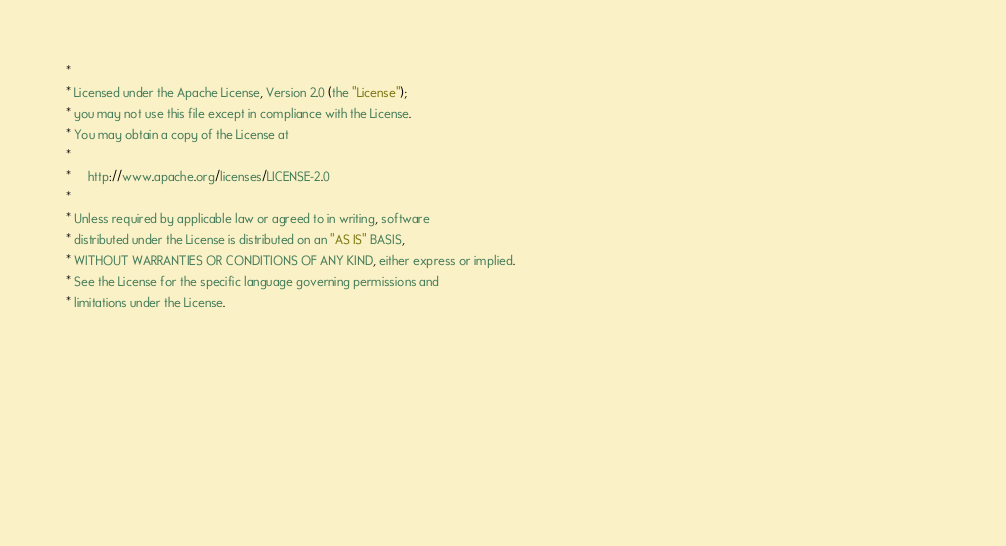Convert code to text. <code><loc_0><loc_0><loc_500><loc_500><_CSS_> *                                                                                                                                                                                                      
 * Licensed under the Apache License, Version 2.0 (the "License");                                                                                                                                      
 * you may not use this file except in compliance with the License.                                                                                                                                     
 * You may obtain a copy of the License at                                                                                                                                                              
 *                                                                                                                                                                                                      
 *     http://www.apache.org/licenses/LICENSE-2.0                                                                                                                                                       
 *                                                                                                                                                                                                      
 * Unless required by applicable law or agreed to in writing, software                                                                                                                                  
 * distributed under the License is distributed on an "AS IS" BASIS,                                                                                                                                    
 * WITHOUT WARRANTIES OR CONDITIONS OF ANY KIND, either express or implied.                                                                                                                             
 * See the License for the specific language governing permissions and                                                                                                                                  
 * limitations under the License.                                                                                                                                                                       
                                                                                                                                                                                                       
                                                                                                                                                                                                       
                                                                                                                                                                                                       
                                                                                                                                                                                                       
                                                                                                                                                                                                       
                                                                                                                                                                                                       
                                                                                                                                                                                                       
                                                                                                                                                                                                       
</code> 